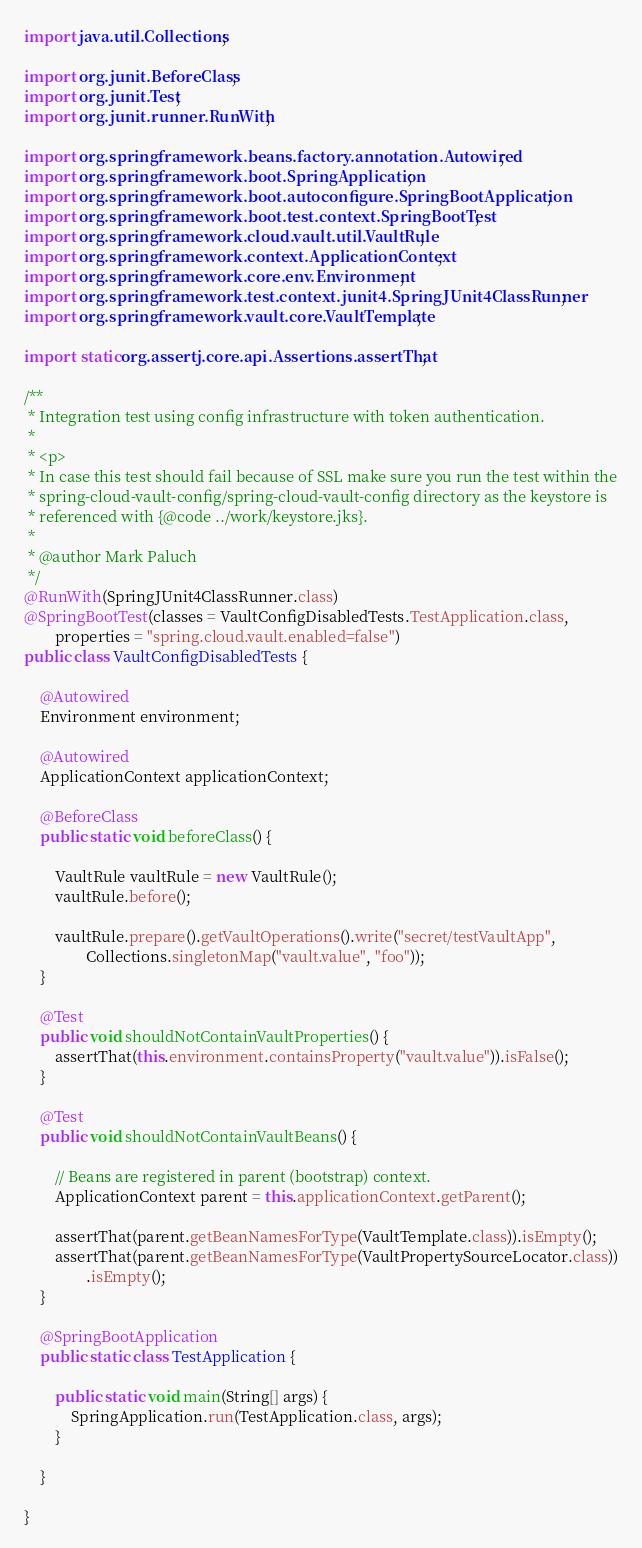<code> <loc_0><loc_0><loc_500><loc_500><_Java_>
import java.util.Collections;

import org.junit.BeforeClass;
import org.junit.Test;
import org.junit.runner.RunWith;

import org.springframework.beans.factory.annotation.Autowired;
import org.springframework.boot.SpringApplication;
import org.springframework.boot.autoconfigure.SpringBootApplication;
import org.springframework.boot.test.context.SpringBootTest;
import org.springframework.cloud.vault.util.VaultRule;
import org.springframework.context.ApplicationContext;
import org.springframework.core.env.Environment;
import org.springframework.test.context.junit4.SpringJUnit4ClassRunner;
import org.springframework.vault.core.VaultTemplate;

import static org.assertj.core.api.Assertions.assertThat;

/**
 * Integration test using config infrastructure with token authentication.
 *
 * <p>
 * In case this test should fail because of SSL make sure you run the test within the
 * spring-cloud-vault-config/spring-cloud-vault-config directory as the keystore is
 * referenced with {@code ../work/keystore.jks}.
 *
 * @author Mark Paluch
 */
@RunWith(SpringJUnit4ClassRunner.class)
@SpringBootTest(classes = VaultConfigDisabledTests.TestApplication.class,
		properties = "spring.cloud.vault.enabled=false")
public class VaultConfigDisabledTests {

	@Autowired
	Environment environment;

	@Autowired
	ApplicationContext applicationContext;

	@BeforeClass
	public static void beforeClass() {

		VaultRule vaultRule = new VaultRule();
		vaultRule.before();

		vaultRule.prepare().getVaultOperations().write("secret/testVaultApp",
				Collections.singletonMap("vault.value", "foo"));
	}

	@Test
	public void shouldNotContainVaultProperties() {
		assertThat(this.environment.containsProperty("vault.value")).isFalse();
	}

	@Test
	public void shouldNotContainVaultBeans() {

		// Beans are registered in parent (bootstrap) context.
		ApplicationContext parent = this.applicationContext.getParent();

		assertThat(parent.getBeanNamesForType(VaultTemplate.class)).isEmpty();
		assertThat(parent.getBeanNamesForType(VaultPropertySourceLocator.class))
				.isEmpty();
	}

	@SpringBootApplication
	public static class TestApplication {

		public static void main(String[] args) {
			SpringApplication.run(TestApplication.class, args);
		}

	}

}
</code> 